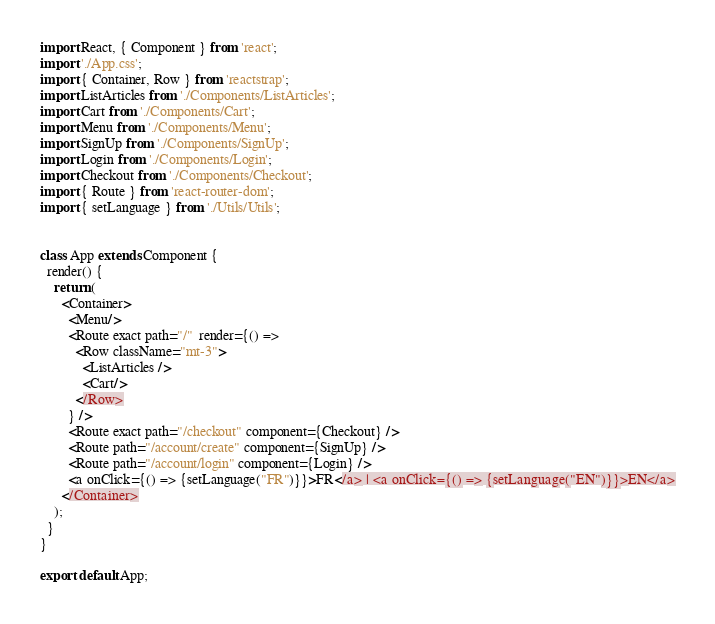<code> <loc_0><loc_0><loc_500><loc_500><_JavaScript_>import React, { Component } from 'react';
import './App.css';
import { Container, Row } from 'reactstrap';
import ListArticles from './Components/ListArticles';
import Cart from './Components/Cart';
import Menu from './Components/Menu';
import SignUp from './Components/SignUp';
import Login from './Components/Login';
import Checkout from './Components/Checkout';
import { Route } from 'react-router-dom';
import { setLanguage } from './Utils/Utils';


class App extends Component {
  render() {
    return (
      <Container>
        <Menu/>
        <Route exact path="/"  render={() => 
          <Row className="mt-3">
            <ListArticles />
            <Cart/>
          </Row>
        } />
        <Route exact path="/checkout" component={Checkout} />
        <Route path="/account/create" component={SignUp} />
        <Route path="/account/login" component={Login} />
        <a onClick={() => {setLanguage("FR")}}>FR</a> | <a onClick={() => {setLanguage("EN")}}>EN</a>
      </Container>
    );
  }
}

export default App;</code> 